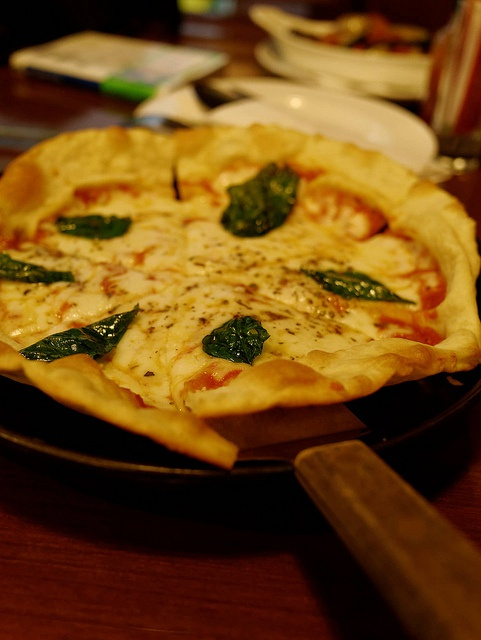Describe the objects in this image and their specific colors. I can see dining table in black, maroon, orange, olive, and tan tones, pizza in black and orange tones, knife in black and maroon tones, and knife in black, maroon, and olive tones in this image. 